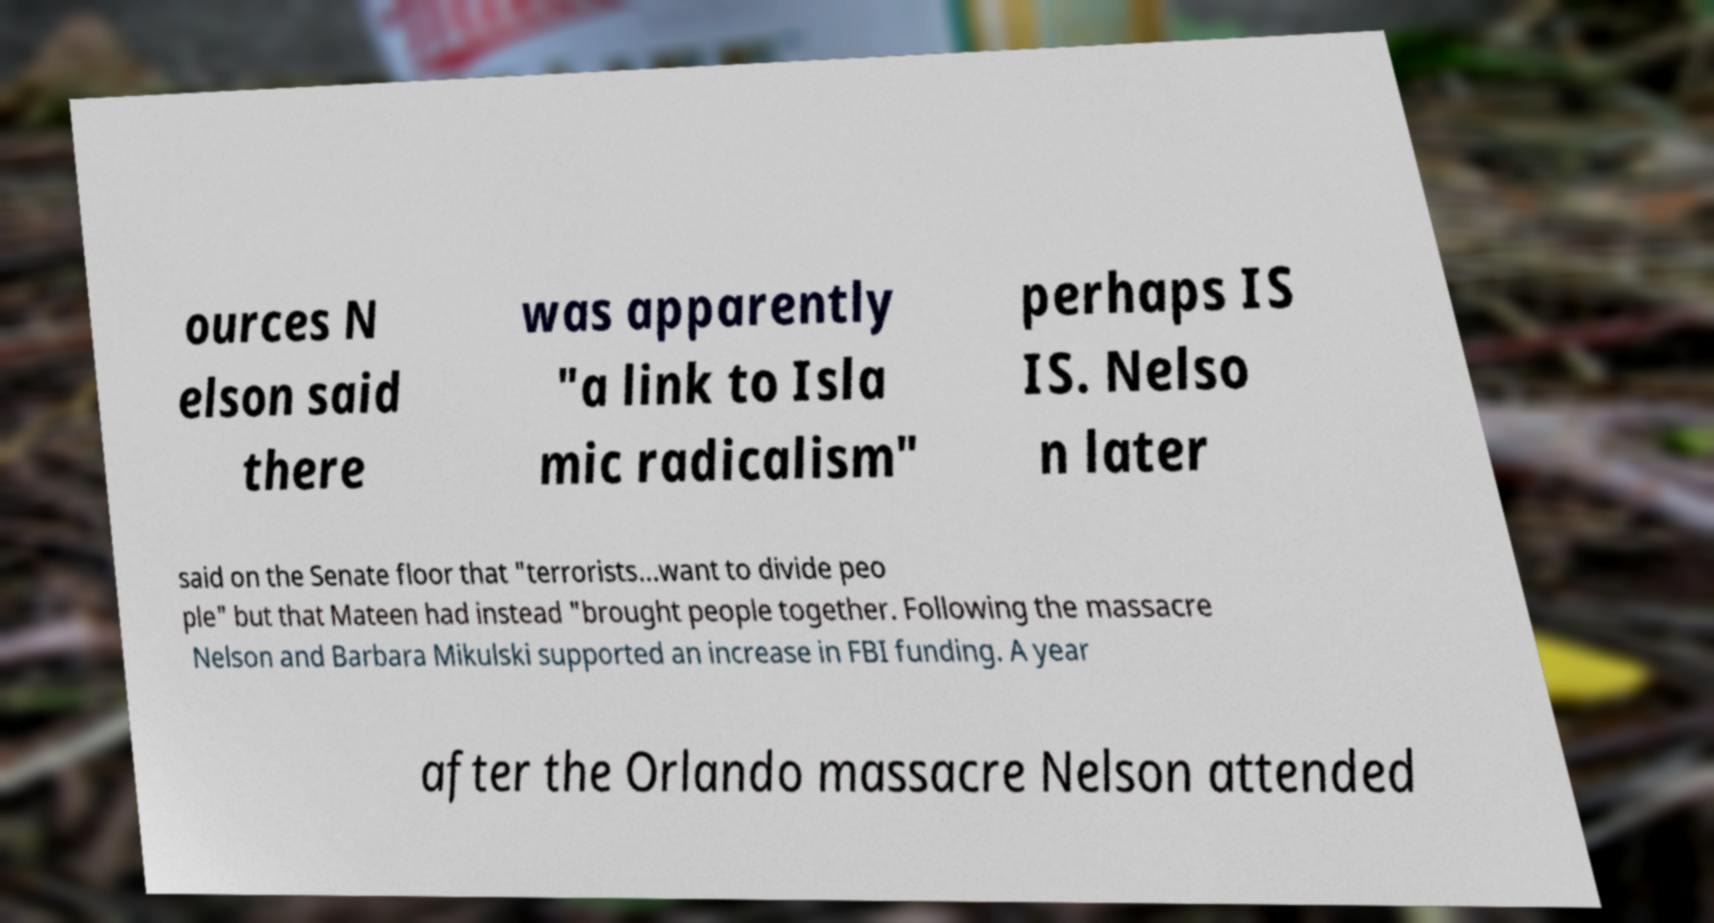There's text embedded in this image that I need extracted. Can you transcribe it verbatim? ources N elson said there was apparently "a link to Isla mic radicalism" perhaps IS IS. Nelso n later said on the Senate floor that "terrorists...want to divide peo ple" but that Mateen had instead "brought people together. Following the massacre Nelson and Barbara Mikulski supported an increase in FBI funding. A year after the Orlando massacre Nelson attended 